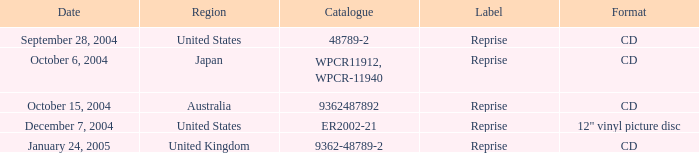Name the catalogue for australia 9362487892.0. 